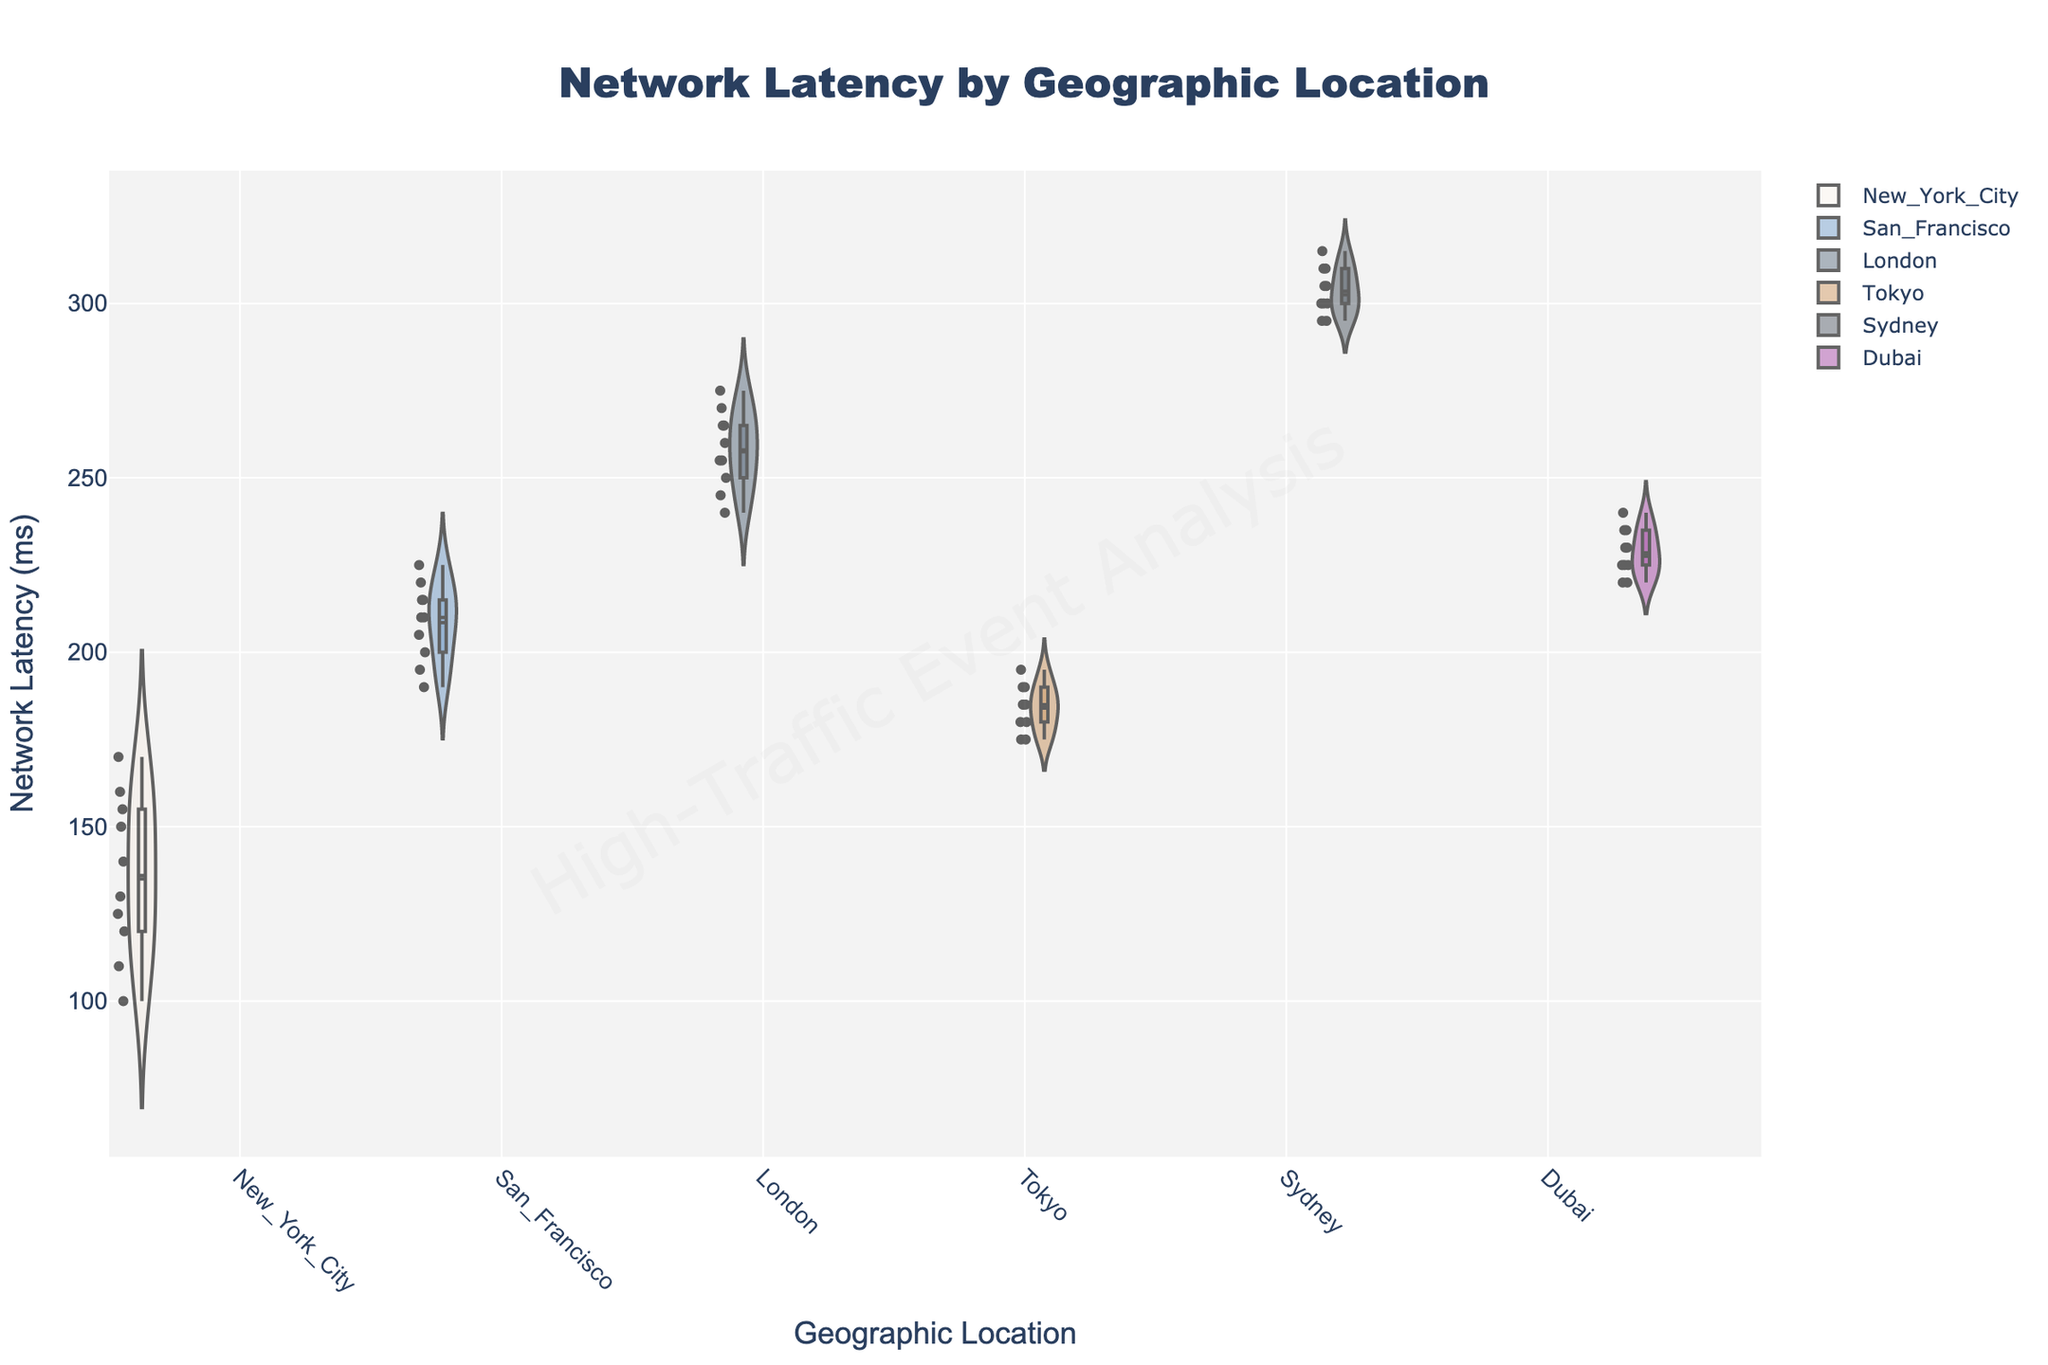What is the title of the chart? The title is displayed at the top center of the figure. It provides an overview of what the chart represents.
Answer: Network Latency by Geographic Location Which geographic location has the highest median network latency? Observe the box plots within the violin plots; the line in the middle of each box represents the median. Sydney's box plot has the highest median line.
Answer: Sydney What is the approximate range of network latency measurements for London? For London's violin plot, identify the vertical spread of the plot. The values range from 240 ms to 275 ms.
Answer: 240 ms to 275 ms Which geographic location exhibits the smallest variability in network latency? Variability is indicated by the spread of the violin plot. Tokyo's plot shows the narrowest range, suggesting the smallest variability.
Answer: Tokyo How does the median network latency in New York City compare to that in San Francisco? Compare the median lines in the box plots for each location. New York City's median is around 140 ms, while San Francisco's is around 210 ms.
Answer: New York City's median is lower Based on the visual representation, which location seems to have the most outliers? Outliers are marked as individual points outside the whiskers of the box plots. Look for the location with the most visible points outside the main distribution. London has several visible outliers.
Answer: London What additional information does the box plot overlay provide on the violin plot? The box plot shows the median, interquartile range (IQR), and potential outliers within the violin plot, which provides a sense of data distribution density. The box plot gives precise quantile values and highlights extreme values.
Answer: Median, IQR, and outliers Which location shows the greatest difference between its minimum and maximum network latency? Compare the overall height from the lowest point to the highest point within each violin plot. Sydney displays the greatest range from about 295 ms to 315 ms.
Answer: Sydney What can be deduced about network performance during high-traffic events in Tokyo based on the plot? Tokyo's violin plot is narrow and centered around a specific range, indicating consistent performance with relatively low variability.
Answer: Low variability and consistent performance 